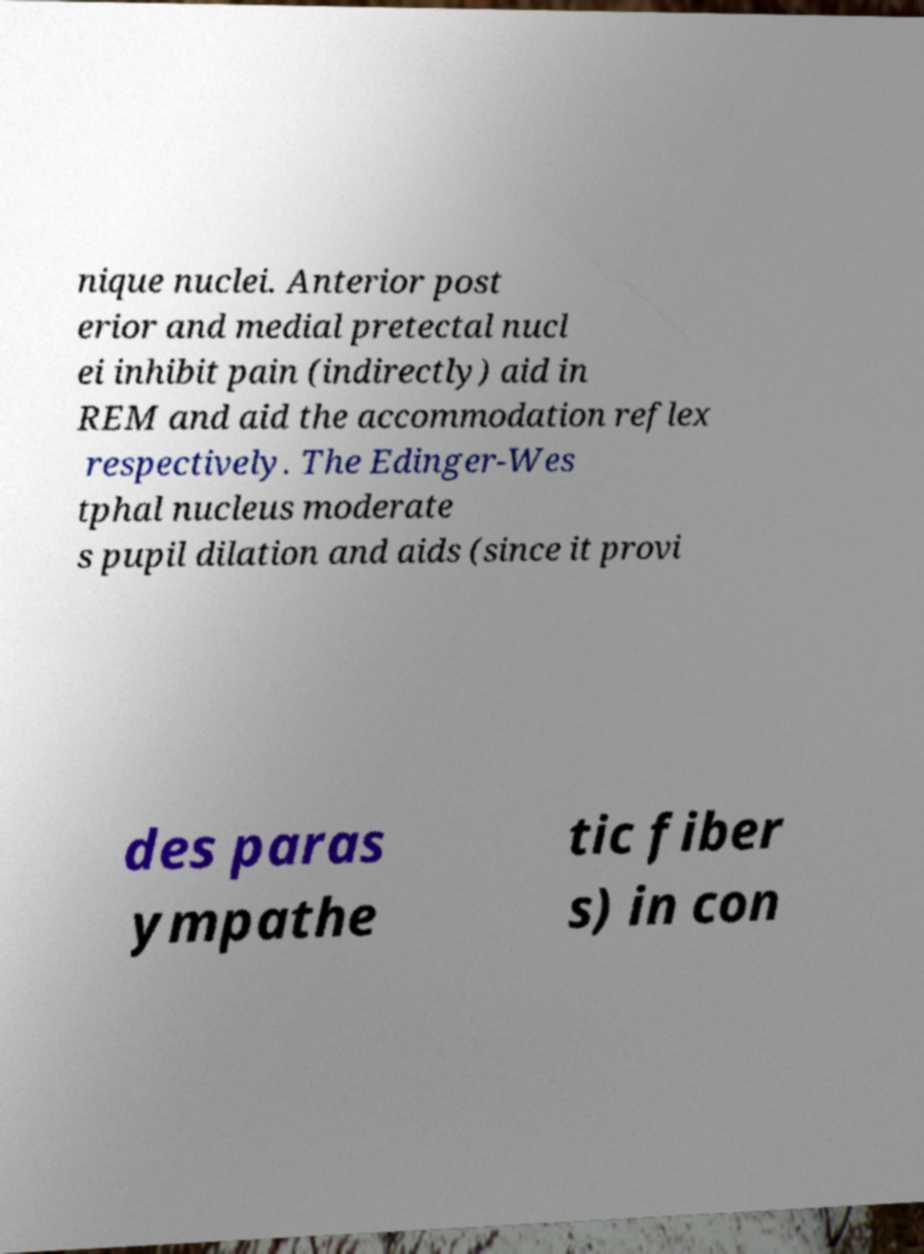Could you extract and type out the text from this image? nique nuclei. Anterior post erior and medial pretectal nucl ei inhibit pain (indirectly) aid in REM and aid the accommodation reflex respectively. The Edinger-Wes tphal nucleus moderate s pupil dilation and aids (since it provi des paras ympathe tic fiber s) in con 